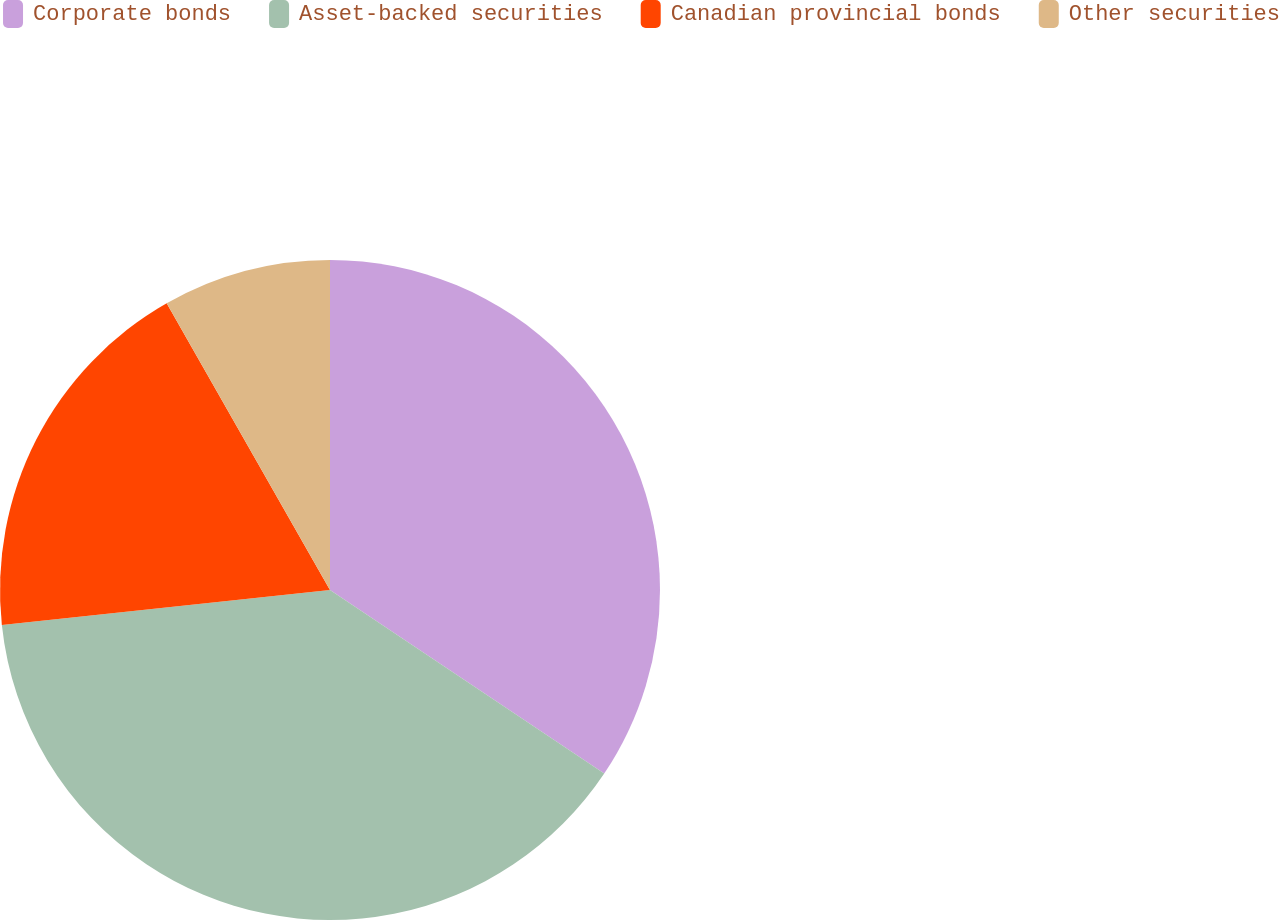Convert chart to OTSL. <chart><loc_0><loc_0><loc_500><loc_500><pie_chart><fcel>Corporate bonds<fcel>Asset-backed securities<fcel>Canadian provincial bonds<fcel>Other securities<nl><fcel>34.39%<fcel>38.92%<fcel>18.45%<fcel>8.24%<nl></chart> 